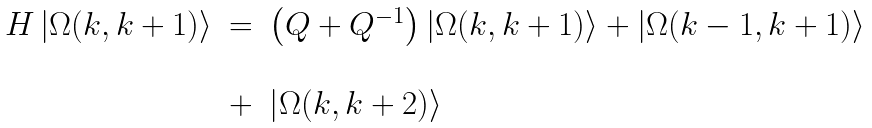Convert formula to latex. <formula><loc_0><loc_0><loc_500><loc_500>\begin{array} { l l l } H \left | \Omega ( k , k + 1 ) \right \rangle & = & \left ( Q + Q ^ { - 1 } \right ) \left | \Omega ( k , k + 1 ) \right \rangle + \left | \Omega ( k - 1 , k + 1 ) \right \rangle \\ & & \\ & + & \left | \Omega ( k , k + 2 ) \right \rangle \end{array}</formula> 